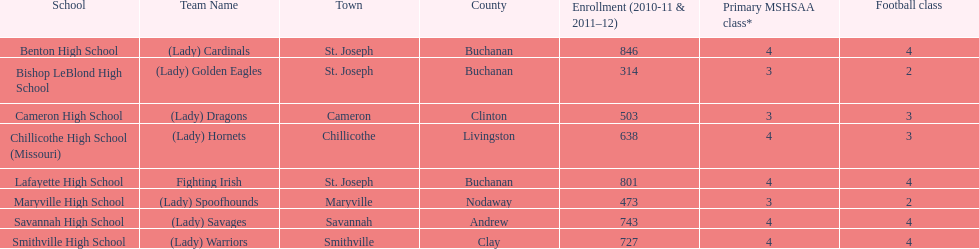How many groups are named after birds? 2. 